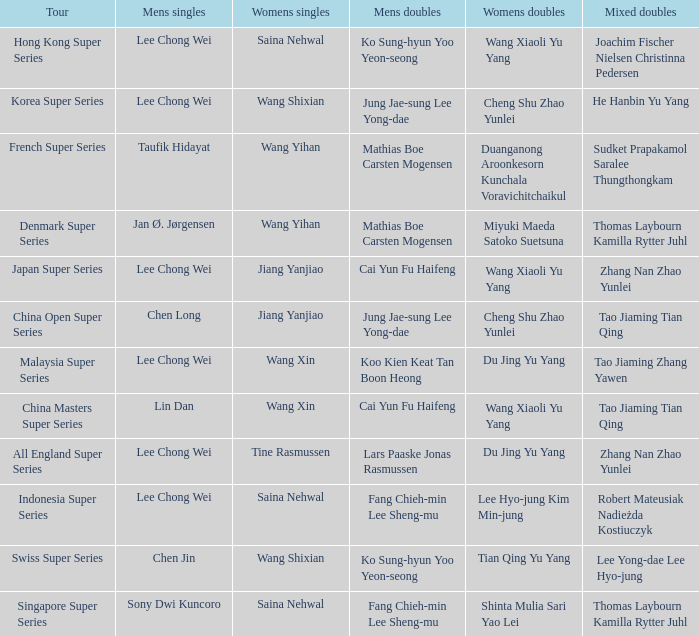Help me parse the entirety of this table. {'header': ['Tour', 'Mens singles', 'Womens singles', 'Mens doubles', 'Womens doubles', 'Mixed doubles'], 'rows': [['Hong Kong Super Series', 'Lee Chong Wei', 'Saina Nehwal', 'Ko Sung-hyun Yoo Yeon-seong', 'Wang Xiaoli Yu Yang', 'Joachim Fischer Nielsen Christinna Pedersen'], ['Korea Super Series', 'Lee Chong Wei', 'Wang Shixian', 'Jung Jae-sung Lee Yong-dae', 'Cheng Shu Zhao Yunlei', 'He Hanbin Yu Yang'], ['French Super Series', 'Taufik Hidayat', 'Wang Yihan', 'Mathias Boe Carsten Mogensen', 'Duanganong Aroonkesorn Kunchala Voravichitchaikul', 'Sudket Prapakamol Saralee Thungthongkam'], ['Denmark Super Series', 'Jan Ø. Jørgensen', 'Wang Yihan', 'Mathias Boe Carsten Mogensen', 'Miyuki Maeda Satoko Suetsuna', 'Thomas Laybourn Kamilla Rytter Juhl'], ['Japan Super Series', 'Lee Chong Wei', 'Jiang Yanjiao', 'Cai Yun Fu Haifeng', 'Wang Xiaoli Yu Yang', 'Zhang Nan Zhao Yunlei'], ['China Open Super Series', 'Chen Long', 'Jiang Yanjiao', 'Jung Jae-sung Lee Yong-dae', 'Cheng Shu Zhao Yunlei', 'Tao Jiaming Tian Qing'], ['Malaysia Super Series', 'Lee Chong Wei', 'Wang Xin', 'Koo Kien Keat Tan Boon Heong', 'Du Jing Yu Yang', 'Tao Jiaming Zhang Yawen'], ['China Masters Super Series', 'Lin Dan', 'Wang Xin', 'Cai Yun Fu Haifeng', 'Wang Xiaoli Yu Yang', 'Tao Jiaming Tian Qing'], ['All England Super Series', 'Lee Chong Wei', 'Tine Rasmussen', 'Lars Paaske Jonas Rasmussen', 'Du Jing Yu Yang', 'Zhang Nan Zhao Yunlei'], ['Indonesia Super Series', 'Lee Chong Wei', 'Saina Nehwal', 'Fang Chieh-min Lee Sheng-mu', 'Lee Hyo-jung Kim Min-jung', 'Robert Mateusiak Nadieżda Kostiuczyk'], ['Swiss Super Series', 'Chen Jin', 'Wang Shixian', 'Ko Sung-hyun Yoo Yeon-seong', 'Tian Qing Yu Yang', 'Lee Yong-dae Lee Hyo-jung'], ['Singapore Super Series', 'Sony Dwi Kuncoro', 'Saina Nehwal', 'Fang Chieh-min Lee Sheng-mu', 'Shinta Mulia Sari Yao Lei', 'Thomas Laybourn Kamilla Rytter Juhl']]} Who is the women's doubles when the mixed doubles are sudket prapakamol saralee thungthongkam? Duanganong Aroonkesorn Kunchala Voravichitchaikul. 